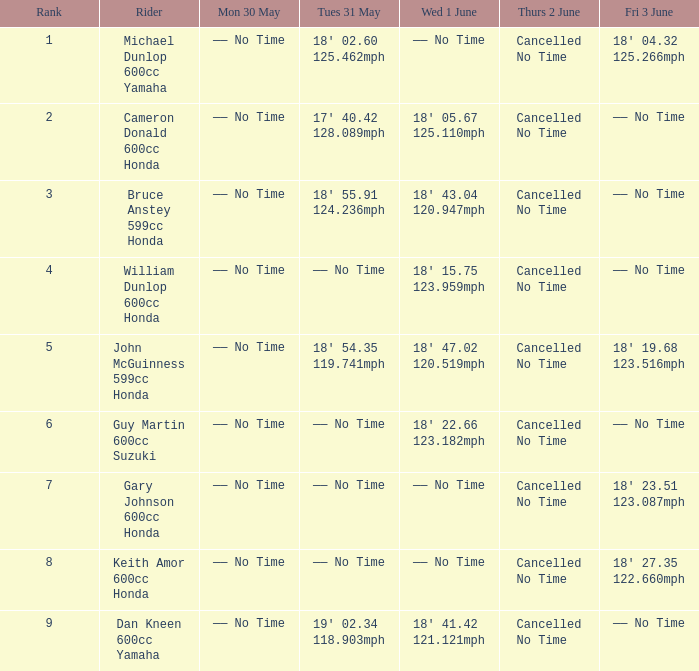Who was the cyclist with a fri 3 june timing of 18' 1 John McGuinness 599cc Honda. 